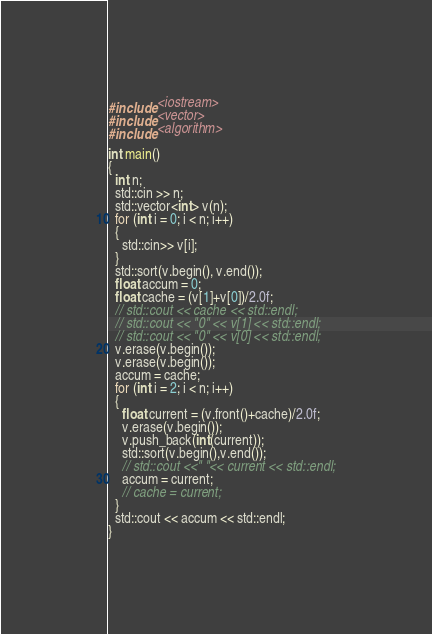<code> <loc_0><loc_0><loc_500><loc_500><_C++_>#include <iostream>
#include <vector>
#include <algorithm>

int main()
{
  int n;
  std::cin >> n;
  std::vector<int> v(n);
  for (int i = 0; i < n; i++)
  {
    std::cin>> v[i];
  }
  std::sort(v.begin(), v.end());
  float accum = 0;
  float cache = (v[1]+v[0])/2.0f;
  // std::cout << cache << std::endl;
  // std::cout << "0" << v[1] << std::endl;
  // std::cout << "0" << v[0] << std::endl;
  v.erase(v.begin());
  v.erase(v.begin());
  accum = cache;
  for (int i = 2; i < n; i++)
  { 
    float current = (v.front()+cache)/2.0f;
    v.erase(v.begin());
    v.push_back(int(current));
    std::sort(v.begin(),v.end());
    // std::cout <<" "<< current << std::endl;
    accum = current;
    // cache = current;
  }
  std::cout << accum << std::endl;
}</code> 